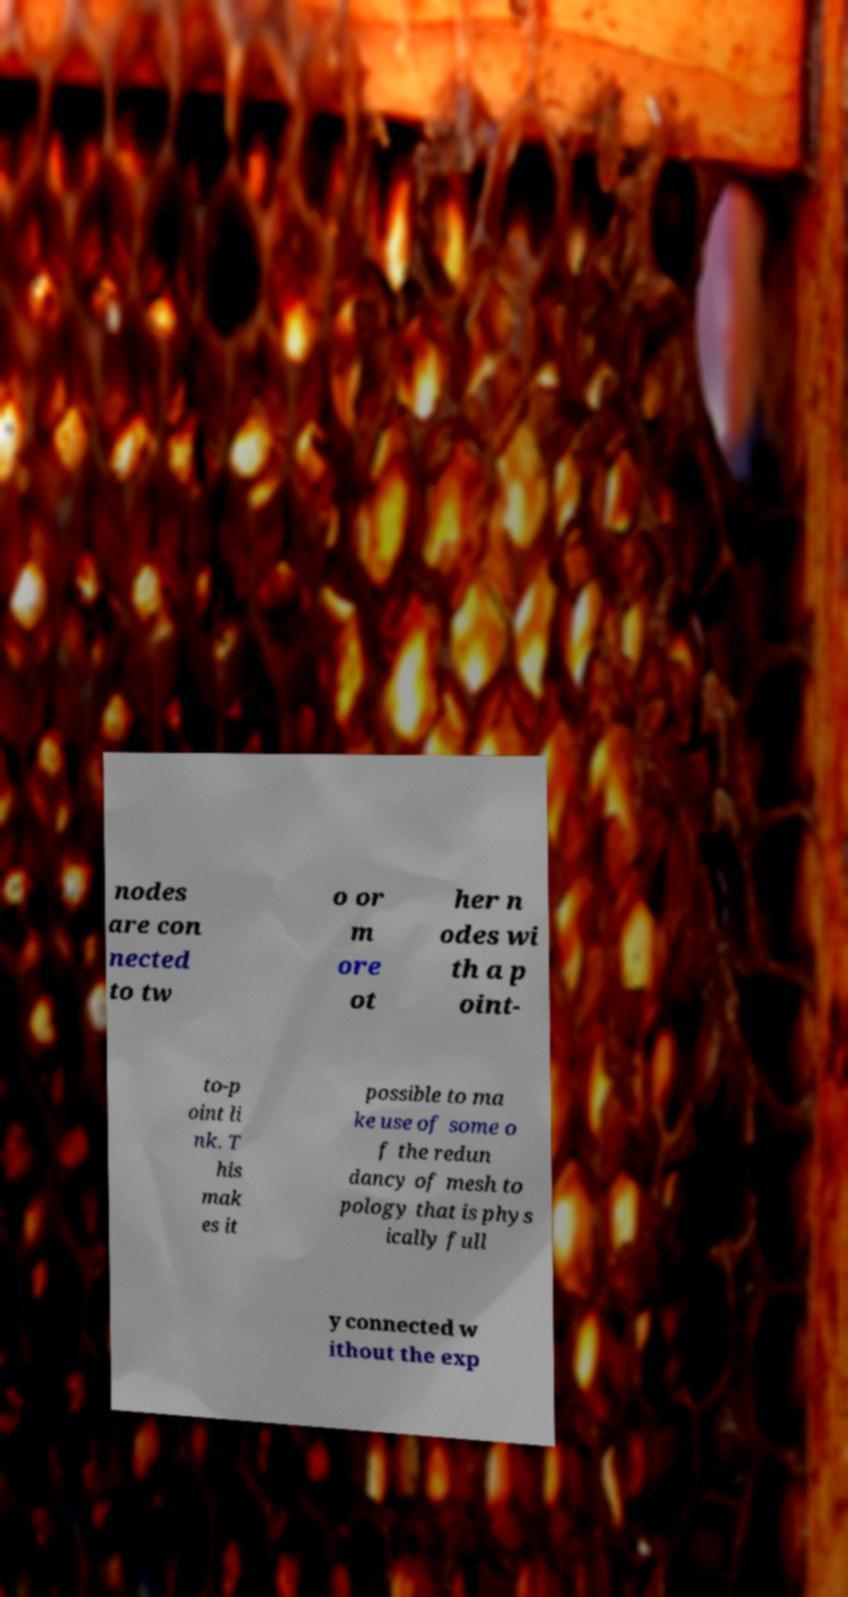There's text embedded in this image that I need extracted. Can you transcribe it verbatim? nodes are con nected to tw o or m ore ot her n odes wi th a p oint- to-p oint li nk. T his mak es it possible to ma ke use of some o f the redun dancy of mesh to pology that is phys ically full y connected w ithout the exp 